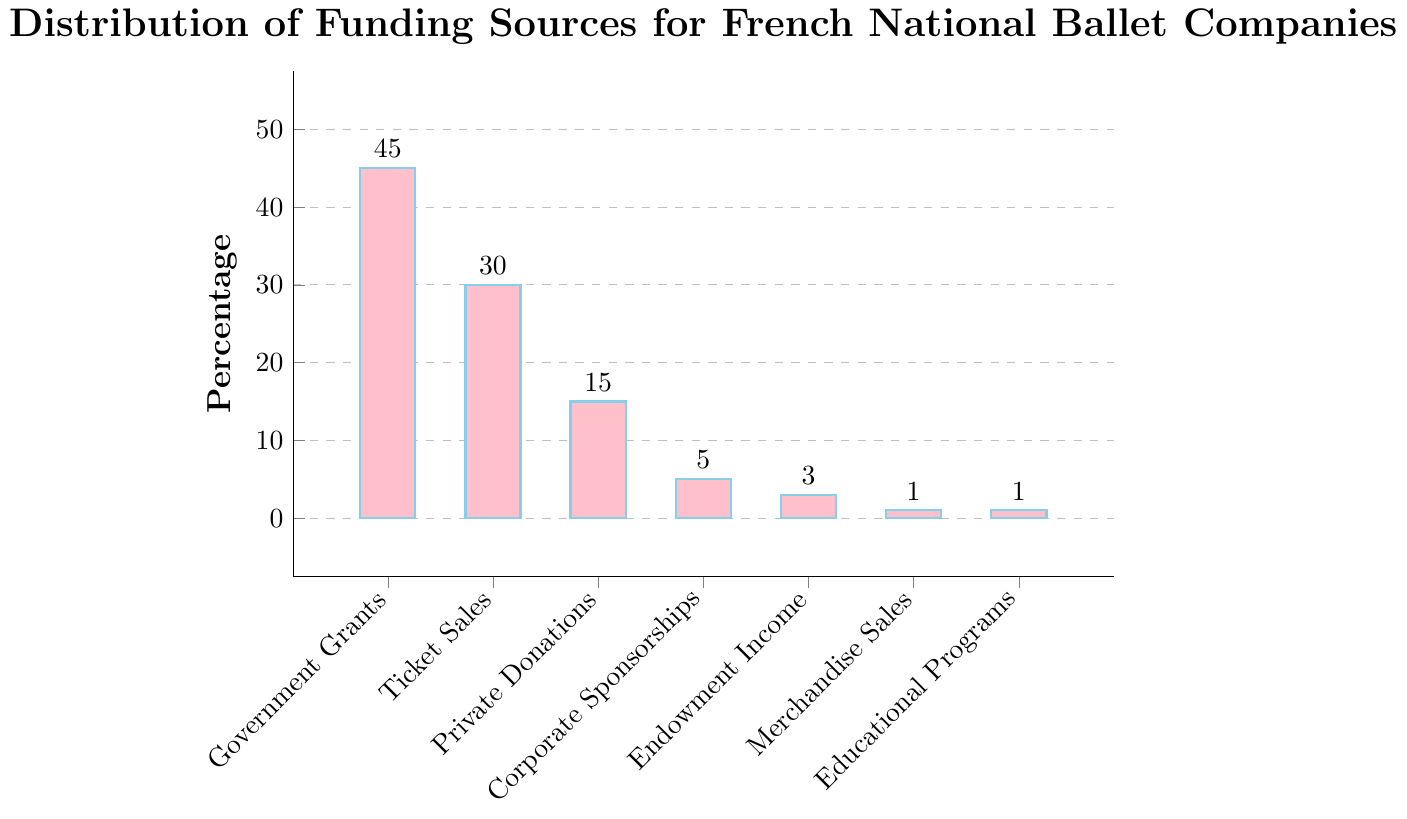What is the largest funding source for French national ballet companies? The largest funding source is the bar that has the highest value in the chart. The bar for Government Grants is the tallest, indicating that it represents the largest funding source with 45%.
Answer: Government Grants Which funding source contributes the least to French national ballet companies? The funding sources with the smallest bars are Merchandise Sales and Educational Programs, each contributing 1%.
Answer: Merchandise Sales and Educational Programs What is the combined percentage of funding from Corporate Sponsorships, Endowment Income, Merchandise Sales, and Educational Programs? Sum the percentages of Corporate Sponsorships (5%), Endowment Income (3%), Merchandise Sales (1%), and Educational Programs (1%): 5 + 3 + 1 + 1 = 10%
Answer: 10% How much more funding does Ticket Sales provide compared to Private Donations? Find the difference between percentages of Ticket Sales (30%) and Private Donations (15%): 30 - 15 = 15%
Answer: 15% What is the difference in percentage between the highest and lowest funding sources? The highest funding source is Government Grants (45%), and the lowest funding sources are Merchandise Sales and Educational Programs (1%). The difference is 45 - 1 = 44%
Answer: 44% Add up the contributions from private funding sources (Private Donations, Corporate Sponsorships, and Merchandise Sales). Sum the percentages of Private Donations (15%), Corporate Sponsorships (5%), and Merchandise Sales (1%): 15 + 5 + 1 = 21%
Answer: 21% Are Government Grants greater than the sum of Corporate Sponsorships and Private Donations? Compare Government Grants (45%) with the sum of Corporate Sponsorships (5%) and Private Donations (15%): 45 > 5 + 15 = 20%
Answer: Yes What is the average contribution percentage of the educational programs and merchandise sales funding sources? Sum the percentages of Educational Programs (1%) and Merchandise Sales (1%), then divide by 2: (1 + 1) / 2 = 1%
Answer: 1% Compare the sum of Ticket Sales and Corporate Sponsorships to Government Grants. Sum Ticket Sales (30%) and Corporate Sponsorships (5%): 30 + 5 = 35%. Compare this sum to Government Grants (45%): 35 < 45%
Answer: Less What portion of the total funding is comprised by Ticket Sales and Endowment Income combined? Sum the percentages of Ticket Sales (30%) and Endowment Income (3%): 30 + 3 = 33%
Answer: 33% 